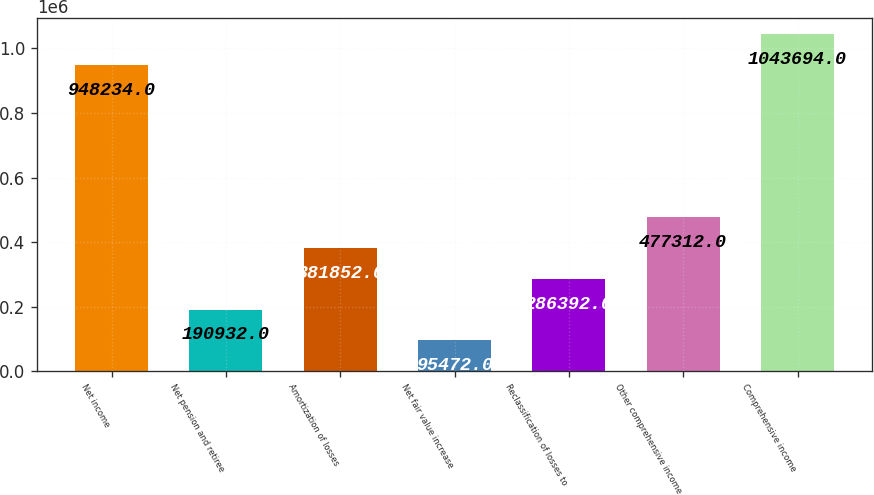Convert chart. <chart><loc_0><loc_0><loc_500><loc_500><bar_chart><fcel>Net income<fcel>Net pension and retiree<fcel>Amortization of losses<fcel>Net fair value increase<fcel>Reclassification of losses to<fcel>Other comprehensive income<fcel>Comprehensive income<nl><fcel>948234<fcel>190932<fcel>381852<fcel>95472<fcel>286392<fcel>477312<fcel>1.04369e+06<nl></chart> 